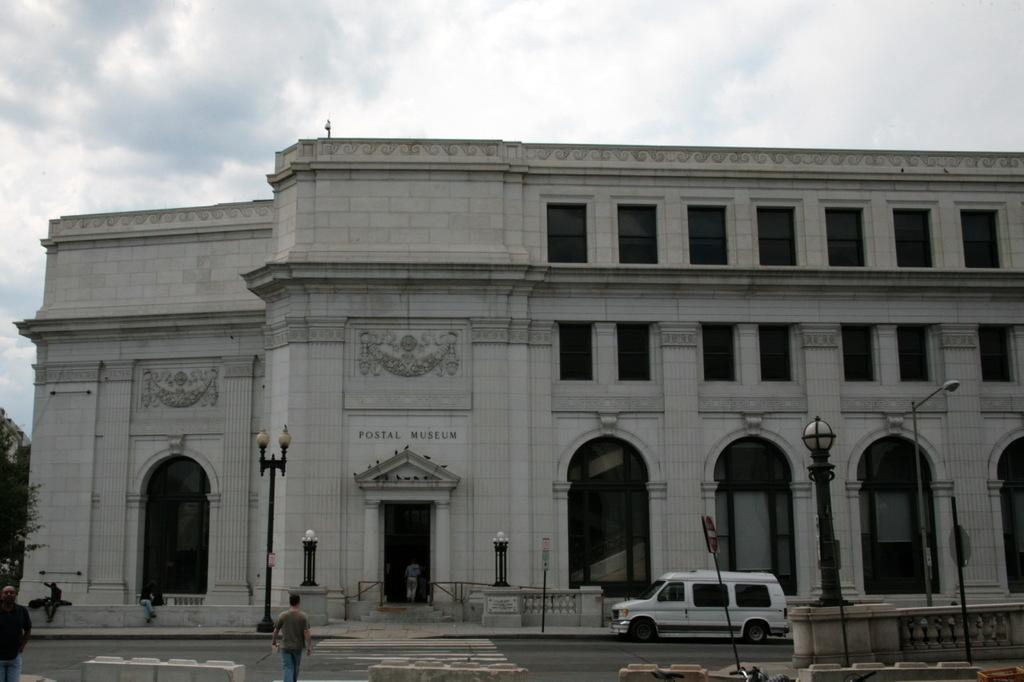<image>
Summarize the visual content of the image. White building with the words POSTAL MUSEUM on the front. 